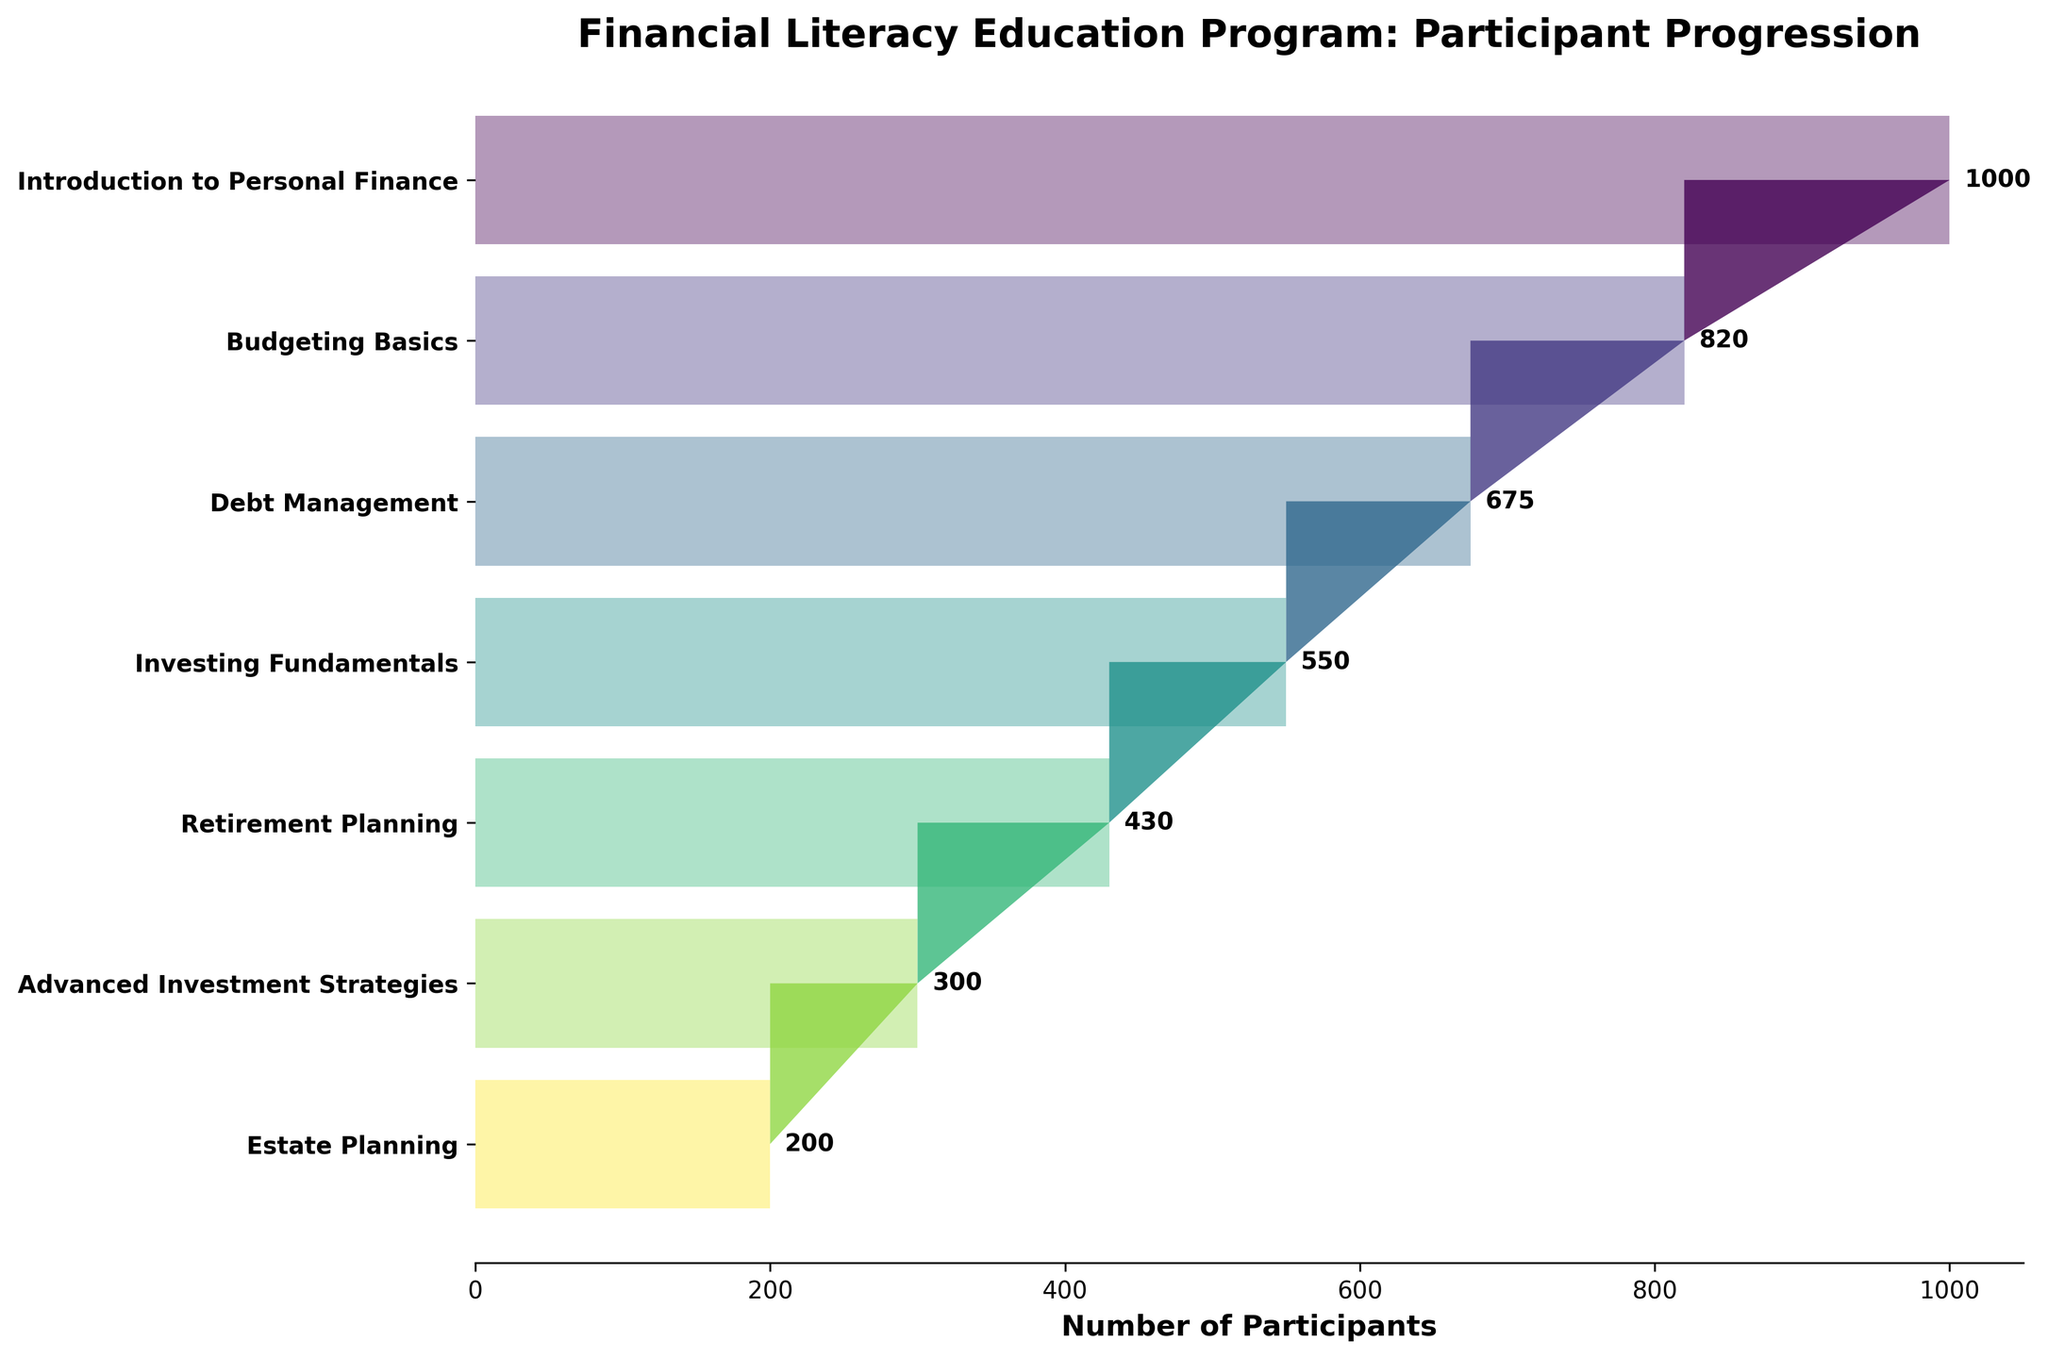What is the title of the chart? The title of the chart is typically located at the top and gives an overview of what the chart represents. It says "Financial Literacy Education Program: Participant Progression."
Answer: Financial Literacy Education Program: Participant Progression Which level has the highest number of participants? The highest number of participants is indicated by the longest horizontal bar at the top of the funnel. It corresponds to the "Introduction to Personal Finance" level with 1000 participants.
Answer: Introduction to Personal Finance Which levels have fewer than 500 participants? Levels with fewer than 500 participants can be identified by the shorter bars on the horizontal axis. These levels include "Retirement Planning," "Advanced Investment Strategies," and "Estate Planning."
Answer: Retirement Planning, Advanced Investment Strategies, Estate Planning What is the difference in the number of participants between "Debt Management" and "Investing Fundamentals"? Refer to the lengths of the bars for both levels. "Debt Management" has 675 participants, and "Investing Fundamentals" has 550 participants. The difference is 675 - 550 = 125 participants.
Answer: 125 Which level marks approximately the halfway point in the participant drop-off? To find the approximate halfway point, look at the middle levels of the funnel. The "Debt Management" level, with 675 participants, is close to the midpoint between the highest and lowest values.
Answer: Debt Management How many levels are detailed in the chart? By counting the number of horizontal bars, you can determine the number of levels presented. There are seven levels in total.
Answer: 7 What percentage of participants move from "Introduction to Personal Finance" to "Budgeting Basics"? Calculate the percentage by taking the number of participants in "Budgeting Basics" (820) and dividing it by the number in "Introduction to Personal Finance" (1000), then multiplying by 100. (820 / 1000) * 100 = 82%.
Answer: 82% How many participants are retained from "Investing Fundamentals" to "Retirement Planning"? The number of participants at "Retirement Planning" (430) is the number retained from "Investing Fundamentals" (550). Calculate the difference: 550 - 430 = 120 participants.
Answer: 120 Which levels show a more than 50% drop in participants compared to the previous level? To find levels with more than a 50% drop, compare the number of participants in each level to its preceding level. "Estate Planning" with 200 participants compared to "Advanced Investment Strategies" with 300 participants shows a drop of 33%, not 50%. No levels have greater than a 50% drop.
Answer: None What is the trend in participant numbers as the course progresses? Observing the lengths of the bars, the trend shows a consistent decrease in the number of participants as they progress through the levels of the program.
Answer: Decreasing 